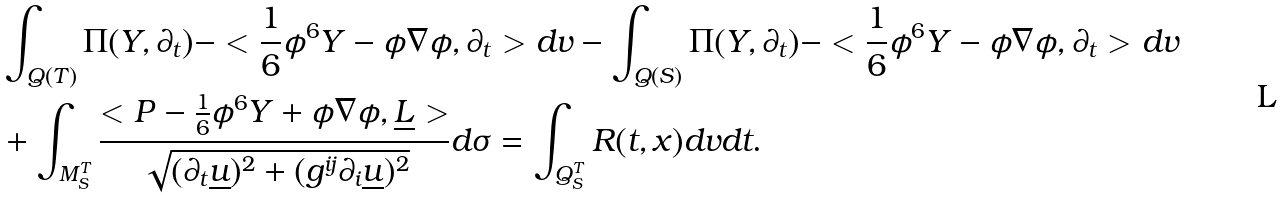<formula> <loc_0><loc_0><loc_500><loc_500>& \int _ { Q ( T ) } \Pi ( Y , \partial _ { t } ) - < \frac { 1 } { 6 } \phi ^ { 6 } Y - \phi \nabla \phi , \partial _ { t } > d v - \int _ { Q ( S ) } \Pi ( Y , \partial _ { t } ) - < \frac { 1 } { 6 } \phi ^ { 6 } Y - \phi \nabla \phi , \partial _ { t } > d v \\ & + \int _ { M _ { S } ^ { T } } \frac { < P - \frac { 1 } { 6 } \phi ^ { 6 } Y + \phi \nabla \phi , \underline { L } > } { \sqrt { ( \partial _ { t } \underline { u } ) ^ { 2 } + ( g ^ { i j } \partial _ { i } \underline { u } ) ^ { 2 } } } d \sigma = \int _ { Q _ { S } ^ { T } } R ( t , x ) d v d t . \\</formula> 